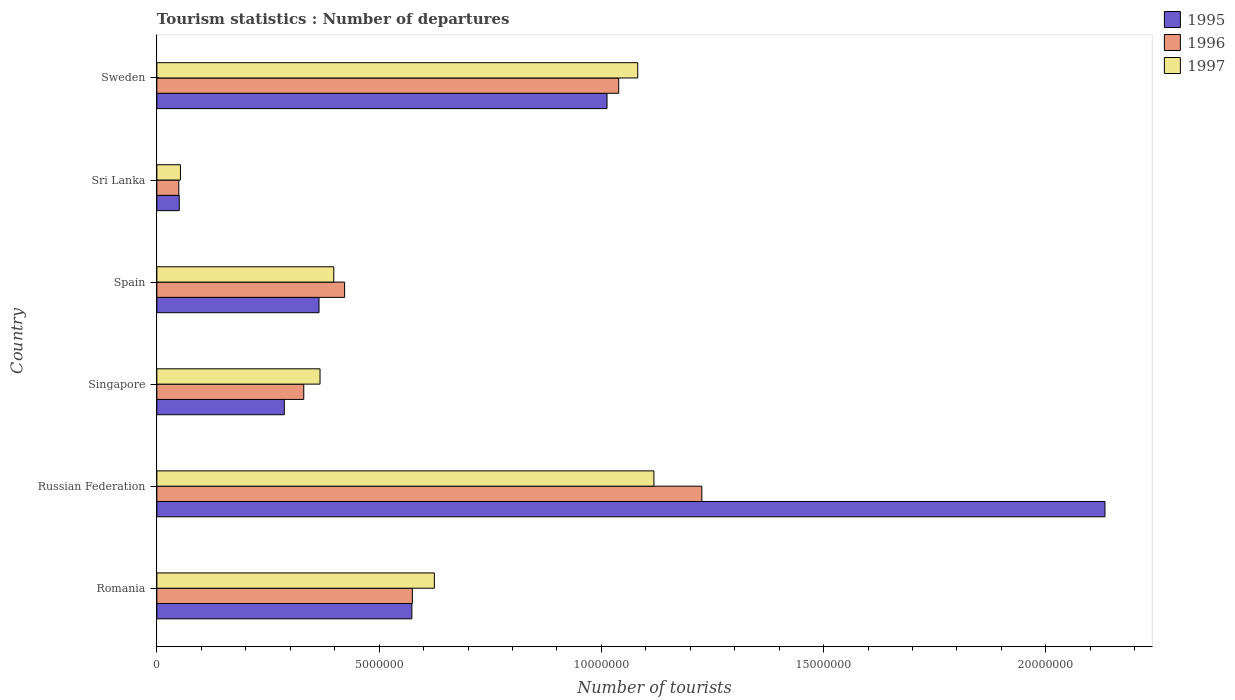How many different coloured bars are there?
Ensure brevity in your answer.  3. Are the number of bars per tick equal to the number of legend labels?
Provide a succinct answer. Yes. How many bars are there on the 1st tick from the top?
Keep it short and to the point. 3. What is the label of the 5th group of bars from the top?
Your response must be concise. Russian Federation. In how many cases, is the number of bars for a given country not equal to the number of legend labels?
Your response must be concise. 0. What is the number of tourist departures in 1996 in Singapore?
Provide a short and direct response. 3.30e+06. Across all countries, what is the maximum number of tourist departures in 1996?
Offer a terse response. 1.23e+07. Across all countries, what is the minimum number of tourist departures in 1997?
Your response must be concise. 5.31e+05. In which country was the number of tourist departures in 1995 maximum?
Provide a succinct answer. Russian Federation. In which country was the number of tourist departures in 1997 minimum?
Provide a short and direct response. Sri Lanka. What is the total number of tourist departures in 1997 in the graph?
Provide a short and direct response. 3.64e+07. What is the difference between the number of tourist departures in 1995 in Sri Lanka and that in Sweden?
Provide a succinct answer. -9.62e+06. What is the difference between the number of tourist departures in 1997 in Spain and the number of tourist departures in 1996 in Singapore?
Your answer should be compact. 6.75e+05. What is the average number of tourist departures in 1997 per country?
Keep it short and to the point. 6.07e+06. What is the difference between the number of tourist departures in 1997 and number of tourist departures in 1996 in Russian Federation?
Your response must be concise. -1.08e+06. What is the ratio of the number of tourist departures in 1997 in Romania to that in Sri Lanka?
Offer a very short reply. 11.76. What is the difference between the highest and the second highest number of tourist departures in 1997?
Give a very brief answer. 3.64e+05. What is the difference between the highest and the lowest number of tourist departures in 1996?
Offer a terse response. 1.18e+07. What does the 2nd bar from the bottom in Singapore represents?
Ensure brevity in your answer.  1996. What is the difference between two consecutive major ticks on the X-axis?
Your answer should be compact. 5.00e+06. Are the values on the major ticks of X-axis written in scientific E-notation?
Provide a succinct answer. No. Where does the legend appear in the graph?
Your response must be concise. Top right. How are the legend labels stacked?
Your answer should be very brief. Vertical. What is the title of the graph?
Your answer should be very brief. Tourism statistics : Number of departures. What is the label or title of the X-axis?
Your answer should be compact. Number of tourists. What is the label or title of the Y-axis?
Ensure brevity in your answer.  Country. What is the Number of tourists in 1995 in Romania?
Offer a terse response. 5.74e+06. What is the Number of tourists in 1996 in Romania?
Provide a succinct answer. 5.75e+06. What is the Number of tourists of 1997 in Romania?
Keep it short and to the point. 6.24e+06. What is the Number of tourists of 1995 in Russian Federation?
Offer a very short reply. 2.13e+07. What is the Number of tourists in 1996 in Russian Federation?
Make the answer very short. 1.23e+07. What is the Number of tourists in 1997 in Russian Federation?
Offer a terse response. 1.12e+07. What is the Number of tourists of 1995 in Singapore?
Your answer should be compact. 2.87e+06. What is the Number of tourists in 1996 in Singapore?
Provide a short and direct response. 3.30e+06. What is the Number of tourists in 1997 in Singapore?
Offer a terse response. 3.67e+06. What is the Number of tourists of 1995 in Spain?
Your response must be concise. 3.65e+06. What is the Number of tourists of 1996 in Spain?
Your answer should be compact. 4.22e+06. What is the Number of tourists of 1997 in Spain?
Ensure brevity in your answer.  3.98e+06. What is the Number of tourists in 1995 in Sri Lanka?
Provide a short and direct response. 5.04e+05. What is the Number of tourists in 1996 in Sri Lanka?
Offer a very short reply. 4.94e+05. What is the Number of tourists of 1997 in Sri Lanka?
Your answer should be compact. 5.31e+05. What is the Number of tourists of 1995 in Sweden?
Provide a short and direct response. 1.01e+07. What is the Number of tourists in 1996 in Sweden?
Provide a succinct answer. 1.04e+07. What is the Number of tourists of 1997 in Sweden?
Your answer should be very brief. 1.08e+07. Across all countries, what is the maximum Number of tourists in 1995?
Make the answer very short. 2.13e+07. Across all countries, what is the maximum Number of tourists in 1996?
Keep it short and to the point. 1.23e+07. Across all countries, what is the maximum Number of tourists of 1997?
Offer a very short reply. 1.12e+07. Across all countries, what is the minimum Number of tourists in 1995?
Keep it short and to the point. 5.04e+05. Across all countries, what is the minimum Number of tourists in 1996?
Make the answer very short. 4.94e+05. Across all countries, what is the minimum Number of tourists of 1997?
Provide a succinct answer. 5.31e+05. What is the total Number of tourists of 1995 in the graph?
Give a very brief answer. 4.42e+07. What is the total Number of tourists of 1996 in the graph?
Your answer should be very brief. 3.64e+07. What is the total Number of tourists in 1997 in the graph?
Provide a short and direct response. 3.64e+07. What is the difference between the Number of tourists in 1995 in Romania and that in Russian Federation?
Provide a succinct answer. -1.56e+07. What is the difference between the Number of tourists in 1996 in Romania and that in Russian Federation?
Make the answer very short. -6.51e+06. What is the difference between the Number of tourists of 1997 in Romania and that in Russian Federation?
Offer a very short reply. -4.94e+06. What is the difference between the Number of tourists of 1995 in Romania and that in Singapore?
Keep it short and to the point. 2.87e+06. What is the difference between the Number of tourists in 1996 in Romania and that in Singapore?
Offer a terse response. 2.44e+06. What is the difference between the Number of tourists of 1997 in Romania and that in Singapore?
Ensure brevity in your answer.  2.57e+06. What is the difference between the Number of tourists in 1995 in Romania and that in Spain?
Offer a very short reply. 2.09e+06. What is the difference between the Number of tourists in 1996 in Romania and that in Spain?
Give a very brief answer. 1.52e+06. What is the difference between the Number of tourists in 1997 in Romania and that in Spain?
Your response must be concise. 2.26e+06. What is the difference between the Number of tourists in 1995 in Romania and that in Sri Lanka?
Your response must be concise. 5.23e+06. What is the difference between the Number of tourists of 1996 in Romania and that in Sri Lanka?
Your answer should be very brief. 5.25e+06. What is the difference between the Number of tourists in 1997 in Romania and that in Sri Lanka?
Keep it short and to the point. 5.71e+06. What is the difference between the Number of tourists of 1995 in Romania and that in Sweden?
Ensure brevity in your answer.  -4.39e+06. What is the difference between the Number of tourists in 1996 in Romania and that in Sweden?
Give a very brief answer. -4.64e+06. What is the difference between the Number of tourists of 1997 in Romania and that in Sweden?
Your answer should be compact. -4.58e+06. What is the difference between the Number of tourists in 1995 in Russian Federation and that in Singapore?
Give a very brief answer. 1.85e+07. What is the difference between the Number of tourists in 1996 in Russian Federation and that in Singapore?
Ensure brevity in your answer.  8.96e+06. What is the difference between the Number of tourists in 1997 in Russian Federation and that in Singapore?
Your response must be concise. 7.51e+06. What is the difference between the Number of tourists in 1995 in Russian Federation and that in Spain?
Ensure brevity in your answer.  1.77e+07. What is the difference between the Number of tourists in 1996 in Russian Federation and that in Spain?
Offer a very short reply. 8.04e+06. What is the difference between the Number of tourists of 1997 in Russian Federation and that in Spain?
Your answer should be very brief. 7.20e+06. What is the difference between the Number of tourists in 1995 in Russian Federation and that in Sri Lanka?
Provide a short and direct response. 2.08e+07. What is the difference between the Number of tourists in 1996 in Russian Federation and that in Sri Lanka?
Keep it short and to the point. 1.18e+07. What is the difference between the Number of tourists in 1997 in Russian Federation and that in Sri Lanka?
Offer a very short reply. 1.07e+07. What is the difference between the Number of tourists of 1995 in Russian Federation and that in Sweden?
Provide a short and direct response. 1.12e+07. What is the difference between the Number of tourists of 1996 in Russian Federation and that in Sweden?
Provide a short and direct response. 1.87e+06. What is the difference between the Number of tourists of 1997 in Russian Federation and that in Sweden?
Give a very brief answer. 3.64e+05. What is the difference between the Number of tourists in 1995 in Singapore and that in Spain?
Keep it short and to the point. -7.81e+05. What is the difference between the Number of tourists in 1996 in Singapore and that in Spain?
Offer a terse response. -9.19e+05. What is the difference between the Number of tourists of 1997 in Singapore and that in Spain?
Your answer should be compact. -3.09e+05. What is the difference between the Number of tourists in 1995 in Singapore and that in Sri Lanka?
Provide a short and direct response. 2.36e+06. What is the difference between the Number of tourists of 1996 in Singapore and that in Sri Lanka?
Offer a terse response. 2.81e+06. What is the difference between the Number of tourists of 1997 in Singapore and that in Sri Lanka?
Your response must be concise. 3.14e+06. What is the difference between the Number of tourists in 1995 in Singapore and that in Sweden?
Make the answer very short. -7.26e+06. What is the difference between the Number of tourists in 1996 in Singapore and that in Sweden?
Offer a very short reply. -7.08e+06. What is the difference between the Number of tourists in 1997 in Singapore and that in Sweden?
Ensure brevity in your answer.  -7.15e+06. What is the difference between the Number of tourists in 1995 in Spain and that in Sri Lanka?
Ensure brevity in your answer.  3.14e+06. What is the difference between the Number of tourists in 1996 in Spain and that in Sri Lanka?
Offer a terse response. 3.73e+06. What is the difference between the Number of tourists in 1997 in Spain and that in Sri Lanka?
Offer a very short reply. 3.45e+06. What is the difference between the Number of tourists of 1995 in Spain and that in Sweden?
Offer a terse response. -6.48e+06. What is the difference between the Number of tourists of 1996 in Spain and that in Sweden?
Ensure brevity in your answer.  -6.17e+06. What is the difference between the Number of tourists of 1997 in Spain and that in Sweden?
Keep it short and to the point. -6.84e+06. What is the difference between the Number of tourists in 1995 in Sri Lanka and that in Sweden?
Your answer should be very brief. -9.62e+06. What is the difference between the Number of tourists in 1996 in Sri Lanka and that in Sweden?
Your answer should be compact. -9.90e+06. What is the difference between the Number of tourists in 1997 in Sri Lanka and that in Sweden?
Provide a short and direct response. -1.03e+07. What is the difference between the Number of tourists of 1995 in Romania and the Number of tourists of 1996 in Russian Federation?
Offer a terse response. -6.52e+06. What is the difference between the Number of tourists in 1995 in Romania and the Number of tourists in 1997 in Russian Federation?
Your answer should be very brief. -5.44e+06. What is the difference between the Number of tourists in 1996 in Romania and the Number of tourists in 1997 in Russian Federation?
Give a very brief answer. -5.43e+06. What is the difference between the Number of tourists of 1995 in Romania and the Number of tourists of 1996 in Singapore?
Your response must be concise. 2.43e+06. What is the difference between the Number of tourists in 1995 in Romania and the Number of tourists in 1997 in Singapore?
Give a very brief answer. 2.07e+06. What is the difference between the Number of tourists of 1996 in Romania and the Number of tourists of 1997 in Singapore?
Give a very brief answer. 2.08e+06. What is the difference between the Number of tourists of 1995 in Romania and the Number of tourists of 1996 in Spain?
Provide a short and direct response. 1.51e+06. What is the difference between the Number of tourists of 1995 in Romania and the Number of tourists of 1997 in Spain?
Offer a very short reply. 1.76e+06. What is the difference between the Number of tourists in 1996 in Romania and the Number of tourists in 1997 in Spain?
Your response must be concise. 1.77e+06. What is the difference between the Number of tourists of 1995 in Romania and the Number of tourists of 1996 in Sri Lanka?
Keep it short and to the point. 5.24e+06. What is the difference between the Number of tourists of 1995 in Romania and the Number of tourists of 1997 in Sri Lanka?
Ensure brevity in your answer.  5.21e+06. What is the difference between the Number of tourists of 1996 in Romania and the Number of tourists of 1997 in Sri Lanka?
Offer a very short reply. 5.22e+06. What is the difference between the Number of tourists in 1995 in Romania and the Number of tourists in 1996 in Sweden?
Make the answer very short. -4.65e+06. What is the difference between the Number of tourists in 1995 in Romania and the Number of tourists in 1997 in Sweden?
Provide a succinct answer. -5.08e+06. What is the difference between the Number of tourists of 1996 in Romania and the Number of tourists of 1997 in Sweden?
Your response must be concise. -5.07e+06. What is the difference between the Number of tourists of 1995 in Russian Federation and the Number of tourists of 1996 in Singapore?
Ensure brevity in your answer.  1.80e+07. What is the difference between the Number of tourists in 1995 in Russian Federation and the Number of tourists in 1997 in Singapore?
Your response must be concise. 1.77e+07. What is the difference between the Number of tourists of 1996 in Russian Federation and the Number of tourists of 1997 in Singapore?
Provide a short and direct response. 8.59e+06. What is the difference between the Number of tourists in 1995 in Russian Federation and the Number of tourists in 1996 in Spain?
Ensure brevity in your answer.  1.71e+07. What is the difference between the Number of tourists of 1995 in Russian Federation and the Number of tourists of 1997 in Spain?
Provide a short and direct response. 1.73e+07. What is the difference between the Number of tourists in 1996 in Russian Federation and the Number of tourists in 1997 in Spain?
Your response must be concise. 8.28e+06. What is the difference between the Number of tourists in 1995 in Russian Federation and the Number of tourists in 1996 in Sri Lanka?
Your answer should be very brief. 2.08e+07. What is the difference between the Number of tourists in 1995 in Russian Federation and the Number of tourists in 1997 in Sri Lanka?
Your answer should be very brief. 2.08e+07. What is the difference between the Number of tourists of 1996 in Russian Federation and the Number of tourists of 1997 in Sri Lanka?
Offer a terse response. 1.17e+07. What is the difference between the Number of tourists in 1995 in Russian Federation and the Number of tourists in 1996 in Sweden?
Offer a terse response. 1.09e+07. What is the difference between the Number of tourists in 1995 in Russian Federation and the Number of tourists in 1997 in Sweden?
Provide a succinct answer. 1.05e+07. What is the difference between the Number of tourists in 1996 in Russian Federation and the Number of tourists in 1997 in Sweden?
Offer a terse response. 1.44e+06. What is the difference between the Number of tourists in 1995 in Singapore and the Number of tourists in 1996 in Spain?
Make the answer very short. -1.36e+06. What is the difference between the Number of tourists in 1995 in Singapore and the Number of tourists in 1997 in Spain?
Give a very brief answer. -1.11e+06. What is the difference between the Number of tourists of 1996 in Singapore and the Number of tourists of 1997 in Spain?
Offer a very short reply. -6.75e+05. What is the difference between the Number of tourists in 1995 in Singapore and the Number of tourists in 1996 in Sri Lanka?
Offer a very short reply. 2.37e+06. What is the difference between the Number of tourists in 1995 in Singapore and the Number of tourists in 1997 in Sri Lanka?
Offer a terse response. 2.34e+06. What is the difference between the Number of tourists of 1996 in Singapore and the Number of tourists of 1997 in Sri Lanka?
Your answer should be very brief. 2.77e+06. What is the difference between the Number of tourists in 1995 in Singapore and the Number of tourists in 1996 in Sweden?
Your response must be concise. -7.52e+06. What is the difference between the Number of tourists in 1995 in Singapore and the Number of tourists in 1997 in Sweden?
Provide a short and direct response. -7.95e+06. What is the difference between the Number of tourists of 1996 in Singapore and the Number of tourists of 1997 in Sweden?
Give a very brief answer. -7.51e+06. What is the difference between the Number of tourists in 1995 in Spain and the Number of tourists in 1996 in Sri Lanka?
Give a very brief answer. 3.15e+06. What is the difference between the Number of tourists in 1995 in Spain and the Number of tourists in 1997 in Sri Lanka?
Offer a terse response. 3.12e+06. What is the difference between the Number of tourists in 1996 in Spain and the Number of tourists in 1997 in Sri Lanka?
Offer a very short reply. 3.69e+06. What is the difference between the Number of tourists in 1995 in Spain and the Number of tourists in 1996 in Sweden?
Offer a very short reply. -6.74e+06. What is the difference between the Number of tourists in 1995 in Spain and the Number of tourists in 1997 in Sweden?
Provide a short and direct response. -7.17e+06. What is the difference between the Number of tourists of 1996 in Spain and the Number of tourists of 1997 in Sweden?
Offer a terse response. -6.59e+06. What is the difference between the Number of tourists in 1995 in Sri Lanka and the Number of tourists in 1996 in Sweden?
Offer a very short reply. -9.89e+06. What is the difference between the Number of tourists in 1995 in Sri Lanka and the Number of tourists in 1997 in Sweden?
Your response must be concise. -1.03e+07. What is the difference between the Number of tourists in 1996 in Sri Lanka and the Number of tourists in 1997 in Sweden?
Make the answer very short. -1.03e+07. What is the average Number of tourists in 1995 per country?
Your response must be concise. 7.37e+06. What is the average Number of tourists in 1996 per country?
Offer a terse response. 6.07e+06. What is the average Number of tourists of 1997 per country?
Make the answer very short. 6.07e+06. What is the difference between the Number of tourists of 1995 and Number of tourists of 1996 in Romania?
Provide a short and direct response. -1.10e+04. What is the difference between the Number of tourists in 1995 and Number of tourists in 1997 in Romania?
Offer a very short reply. -5.06e+05. What is the difference between the Number of tourists in 1996 and Number of tourists in 1997 in Romania?
Provide a succinct answer. -4.95e+05. What is the difference between the Number of tourists of 1995 and Number of tourists of 1996 in Russian Federation?
Keep it short and to the point. 9.07e+06. What is the difference between the Number of tourists of 1995 and Number of tourists of 1997 in Russian Federation?
Your response must be concise. 1.01e+07. What is the difference between the Number of tourists of 1996 and Number of tourists of 1997 in Russian Federation?
Make the answer very short. 1.08e+06. What is the difference between the Number of tourists in 1995 and Number of tourists in 1996 in Singapore?
Ensure brevity in your answer.  -4.38e+05. What is the difference between the Number of tourists of 1995 and Number of tourists of 1997 in Singapore?
Provide a short and direct response. -8.04e+05. What is the difference between the Number of tourists in 1996 and Number of tourists in 1997 in Singapore?
Offer a terse response. -3.66e+05. What is the difference between the Number of tourists of 1995 and Number of tourists of 1996 in Spain?
Ensure brevity in your answer.  -5.76e+05. What is the difference between the Number of tourists of 1995 and Number of tourists of 1997 in Spain?
Provide a short and direct response. -3.32e+05. What is the difference between the Number of tourists of 1996 and Number of tourists of 1997 in Spain?
Your response must be concise. 2.44e+05. What is the difference between the Number of tourists of 1995 and Number of tourists of 1997 in Sri Lanka?
Your answer should be very brief. -2.70e+04. What is the difference between the Number of tourists of 1996 and Number of tourists of 1997 in Sri Lanka?
Give a very brief answer. -3.70e+04. What is the difference between the Number of tourists in 1995 and Number of tourists in 1996 in Sweden?
Give a very brief answer. -2.63e+05. What is the difference between the Number of tourists of 1995 and Number of tourists of 1997 in Sweden?
Your answer should be compact. -6.91e+05. What is the difference between the Number of tourists in 1996 and Number of tourists in 1997 in Sweden?
Make the answer very short. -4.28e+05. What is the ratio of the Number of tourists of 1995 in Romania to that in Russian Federation?
Provide a succinct answer. 0.27. What is the ratio of the Number of tourists of 1996 in Romania to that in Russian Federation?
Keep it short and to the point. 0.47. What is the ratio of the Number of tourists in 1997 in Romania to that in Russian Federation?
Offer a very short reply. 0.56. What is the ratio of the Number of tourists of 1995 in Romania to that in Singapore?
Offer a terse response. 2. What is the ratio of the Number of tourists in 1996 in Romania to that in Singapore?
Offer a terse response. 1.74. What is the ratio of the Number of tourists in 1997 in Romania to that in Singapore?
Offer a terse response. 1.7. What is the ratio of the Number of tourists in 1995 in Romania to that in Spain?
Your response must be concise. 1.57. What is the ratio of the Number of tourists of 1996 in Romania to that in Spain?
Provide a succinct answer. 1.36. What is the ratio of the Number of tourists of 1997 in Romania to that in Spain?
Make the answer very short. 1.57. What is the ratio of the Number of tourists of 1995 in Romania to that in Sri Lanka?
Your answer should be very brief. 11.38. What is the ratio of the Number of tourists in 1996 in Romania to that in Sri Lanka?
Offer a terse response. 11.64. What is the ratio of the Number of tourists of 1997 in Romania to that in Sri Lanka?
Your answer should be compact. 11.76. What is the ratio of the Number of tourists of 1995 in Romania to that in Sweden?
Your answer should be compact. 0.57. What is the ratio of the Number of tourists in 1996 in Romania to that in Sweden?
Ensure brevity in your answer.  0.55. What is the ratio of the Number of tourists in 1997 in Romania to that in Sweden?
Provide a short and direct response. 0.58. What is the ratio of the Number of tourists in 1995 in Russian Federation to that in Singapore?
Ensure brevity in your answer.  7.44. What is the ratio of the Number of tourists in 1996 in Russian Federation to that in Singapore?
Your answer should be compact. 3.71. What is the ratio of the Number of tourists in 1997 in Russian Federation to that in Singapore?
Your response must be concise. 3.05. What is the ratio of the Number of tourists of 1995 in Russian Federation to that in Spain?
Provide a short and direct response. 5.85. What is the ratio of the Number of tourists of 1996 in Russian Federation to that in Spain?
Your answer should be compact. 2.9. What is the ratio of the Number of tourists in 1997 in Russian Federation to that in Spain?
Offer a terse response. 2.81. What is the ratio of the Number of tourists of 1995 in Russian Federation to that in Sri Lanka?
Make the answer very short. 42.32. What is the ratio of the Number of tourists in 1996 in Russian Federation to that in Sri Lanka?
Keep it short and to the point. 24.82. What is the ratio of the Number of tourists in 1997 in Russian Federation to that in Sri Lanka?
Make the answer very short. 21.06. What is the ratio of the Number of tourists of 1995 in Russian Federation to that in Sweden?
Ensure brevity in your answer.  2.11. What is the ratio of the Number of tourists in 1996 in Russian Federation to that in Sweden?
Make the answer very short. 1.18. What is the ratio of the Number of tourists of 1997 in Russian Federation to that in Sweden?
Make the answer very short. 1.03. What is the ratio of the Number of tourists of 1995 in Singapore to that in Spain?
Ensure brevity in your answer.  0.79. What is the ratio of the Number of tourists of 1996 in Singapore to that in Spain?
Offer a very short reply. 0.78. What is the ratio of the Number of tourists of 1997 in Singapore to that in Spain?
Provide a short and direct response. 0.92. What is the ratio of the Number of tourists in 1995 in Singapore to that in Sri Lanka?
Your answer should be compact. 5.69. What is the ratio of the Number of tourists of 1996 in Singapore to that in Sri Lanka?
Give a very brief answer. 6.69. What is the ratio of the Number of tourists of 1997 in Singapore to that in Sri Lanka?
Offer a terse response. 6.91. What is the ratio of the Number of tourists in 1995 in Singapore to that in Sweden?
Provide a succinct answer. 0.28. What is the ratio of the Number of tourists of 1996 in Singapore to that in Sweden?
Keep it short and to the point. 0.32. What is the ratio of the Number of tourists in 1997 in Singapore to that in Sweden?
Ensure brevity in your answer.  0.34. What is the ratio of the Number of tourists of 1995 in Spain to that in Sri Lanka?
Your answer should be very brief. 7.24. What is the ratio of the Number of tourists of 1996 in Spain to that in Sri Lanka?
Provide a succinct answer. 8.55. What is the ratio of the Number of tourists in 1997 in Spain to that in Sri Lanka?
Your answer should be compact. 7.5. What is the ratio of the Number of tourists of 1995 in Spain to that in Sweden?
Give a very brief answer. 0.36. What is the ratio of the Number of tourists of 1996 in Spain to that in Sweden?
Provide a succinct answer. 0.41. What is the ratio of the Number of tourists of 1997 in Spain to that in Sweden?
Make the answer very short. 0.37. What is the ratio of the Number of tourists of 1995 in Sri Lanka to that in Sweden?
Your answer should be very brief. 0.05. What is the ratio of the Number of tourists in 1996 in Sri Lanka to that in Sweden?
Provide a succinct answer. 0.05. What is the ratio of the Number of tourists in 1997 in Sri Lanka to that in Sweden?
Make the answer very short. 0.05. What is the difference between the highest and the second highest Number of tourists of 1995?
Your response must be concise. 1.12e+07. What is the difference between the highest and the second highest Number of tourists in 1996?
Provide a short and direct response. 1.87e+06. What is the difference between the highest and the second highest Number of tourists of 1997?
Your answer should be compact. 3.64e+05. What is the difference between the highest and the lowest Number of tourists in 1995?
Make the answer very short. 2.08e+07. What is the difference between the highest and the lowest Number of tourists in 1996?
Your response must be concise. 1.18e+07. What is the difference between the highest and the lowest Number of tourists in 1997?
Make the answer very short. 1.07e+07. 